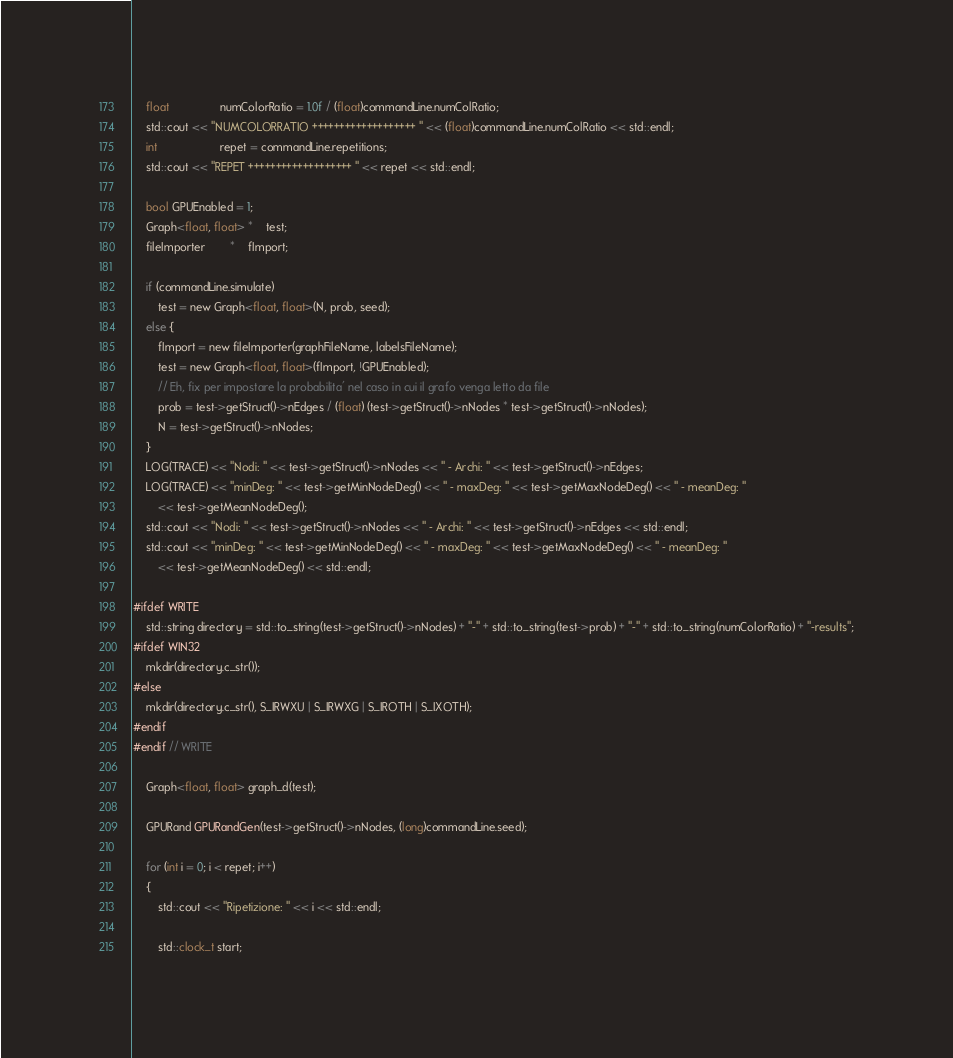<code> <loc_0><loc_0><loc_500><loc_500><_Cuda_>	float				numColorRatio = 1.0f / (float)commandLine.numColRatio;
	std::cout << "NUMCOLORRATIO +++++++++++++++++++ " << (float)commandLine.numColRatio << std::endl;
	int					repet = commandLine.repetitions;
	std::cout << "REPET +++++++++++++++++++ " << repet << std::endl;

	bool GPUEnabled = 1;
	Graph<float, float> *	test;
	fileImporter 		*	fImport;

	if (commandLine.simulate)
		test = new Graph<float, float>(N, prob, seed);
	else {
		fImport = new fileImporter(graphFileName, labelsFileName);
		test = new Graph<float, float>(fImport, !GPUEnabled);
		// Eh, fix per impostare la probabilita' nel caso in cui il grafo venga letto da file
		prob = test->getStruct()->nEdges / (float) (test->getStruct()->nNodes * test->getStruct()->nNodes);
		N = test->getStruct()->nNodes;
	}
	LOG(TRACE) << "Nodi: " << test->getStruct()->nNodes << " - Archi: " << test->getStruct()->nEdges;
	LOG(TRACE) << "minDeg: " << test->getMinNodeDeg() << " - maxDeg: " << test->getMaxNodeDeg() << " - meanDeg: "
		<< test->getMeanNodeDeg();
	std::cout << "Nodi: " << test->getStruct()->nNodes << " - Archi: " << test->getStruct()->nEdges << std::endl;
	std::cout << "minDeg: " << test->getMinNodeDeg() << " - maxDeg: " << test->getMaxNodeDeg() << " - meanDeg: "
		<< test->getMeanNodeDeg() << std::endl;

#ifdef WRITE
	std::string directory = std::to_string(test->getStruct()->nNodes) + "-" + std::to_string(test->prob) + "-" + std::to_string(numColorRatio) + "-results";
#ifdef WIN32
	mkdir(directory.c_str());
#else
	mkdir(directory.c_str(), S_IRWXU | S_IRWXG | S_IROTH | S_IXOTH);
#endif
#endif // WRITE

	Graph<float, float> graph_d(test);

	GPURand GPURandGen(test->getStruct()->nNodes, (long)commandLine.seed);

	for (int i = 0; i < repet; i++)
	{
		std::cout << "Ripetizione: " << i << std::endl;

		std::clock_t start;</code> 